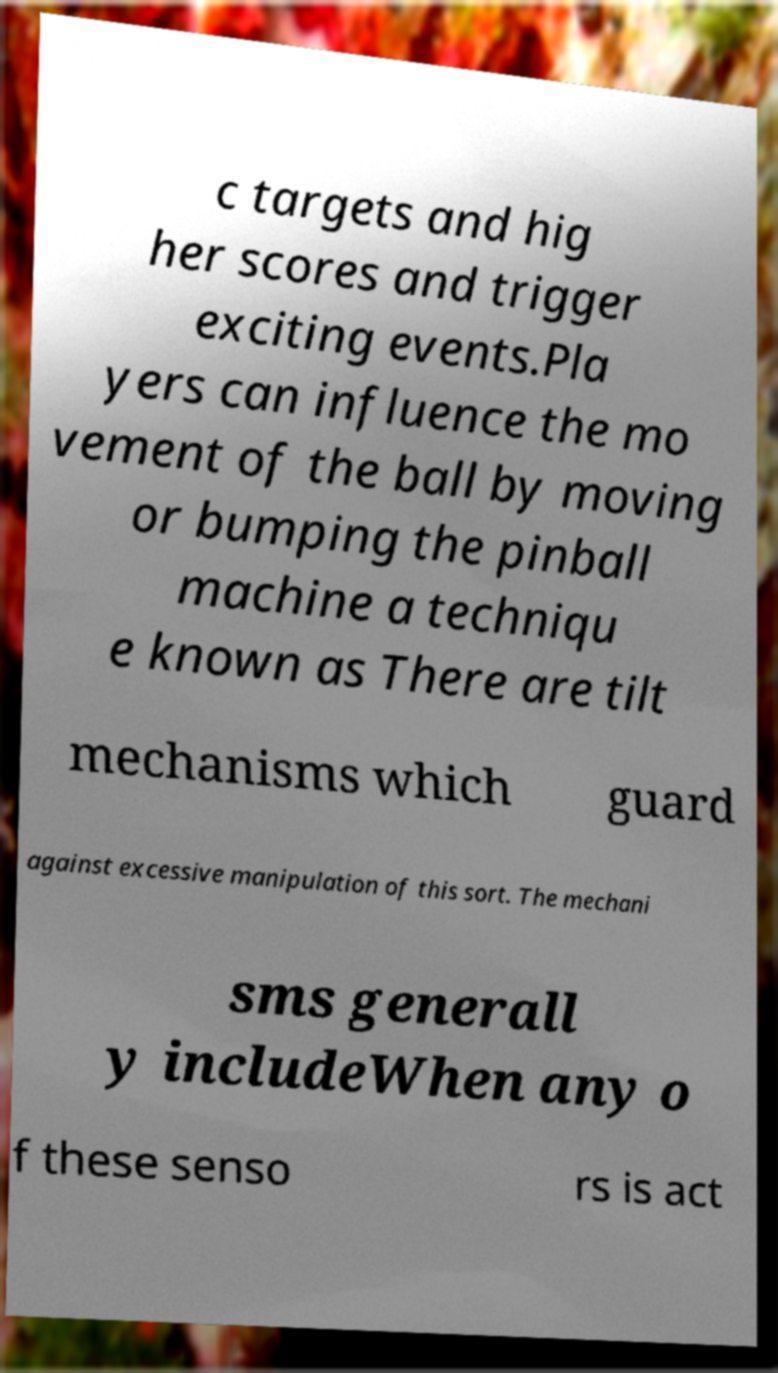Can you accurately transcribe the text from the provided image for me? c targets and hig her scores and trigger exciting events.Pla yers can influence the mo vement of the ball by moving or bumping the pinball machine a techniqu e known as There are tilt mechanisms which guard against excessive manipulation of this sort. The mechani sms generall y includeWhen any o f these senso rs is act 